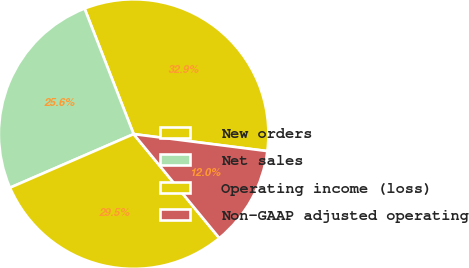Convert chart to OTSL. <chart><loc_0><loc_0><loc_500><loc_500><pie_chart><fcel>New orders<fcel>Net sales<fcel>Operating income (loss)<fcel>Non-GAAP adjusted operating<nl><fcel>32.95%<fcel>25.58%<fcel>29.46%<fcel>12.02%<nl></chart> 